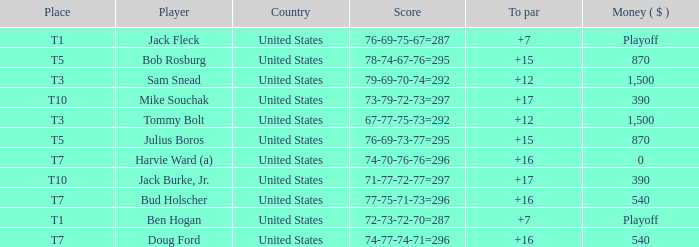Which money has player Jack Fleck with t1 place? Playoff. 